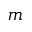<formula> <loc_0><loc_0><loc_500><loc_500>m</formula> 